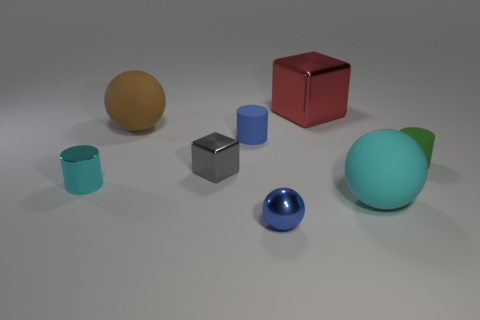Subtract all matte cylinders. How many cylinders are left? 1 Subtract 1 cylinders. How many cylinders are left? 2 Add 1 cubes. How many objects exist? 9 Subtract 0 green cubes. How many objects are left? 8 Subtract all blocks. How many objects are left? 6 Subtract all metallic cylinders. Subtract all small blue cylinders. How many objects are left? 6 Add 4 metallic cylinders. How many metallic cylinders are left? 5 Add 4 metallic balls. How many metallic balls exist? 5 